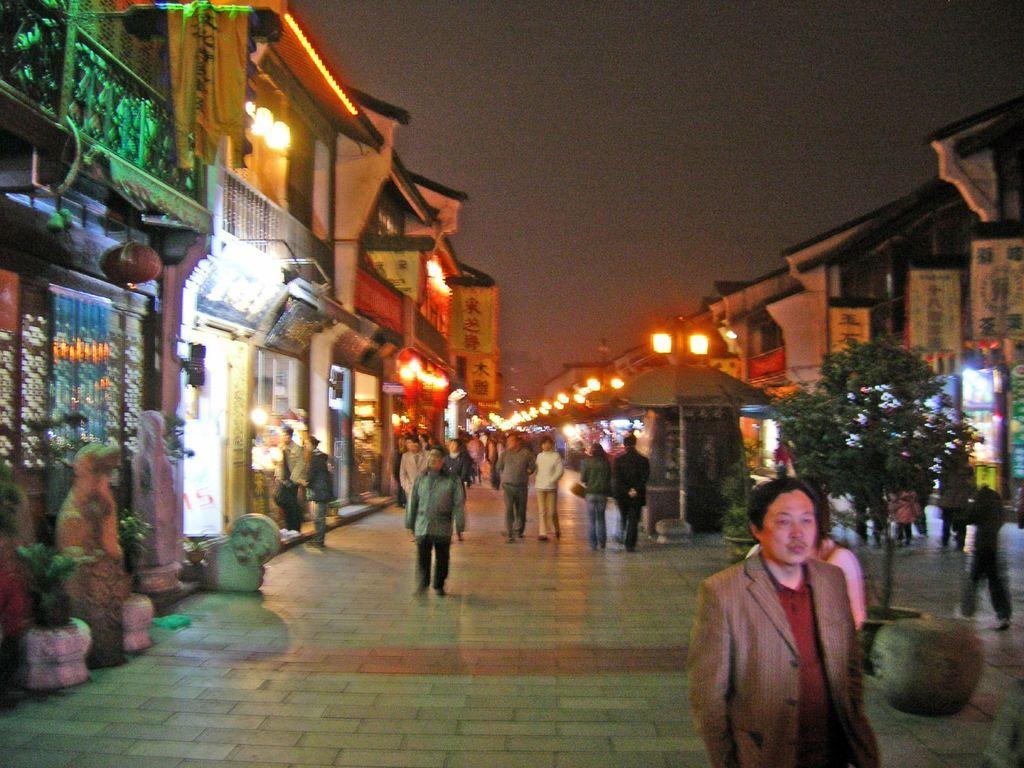Can you describe this image briefly? In the center of the image we can see a few people are walking on the road and a few people are holding some objects.. In the background, we can see the sky, buildings, fences, lights, poles, one tree, one outdoor umbrella, plant pots, sculptures, banners and a few other objects. 